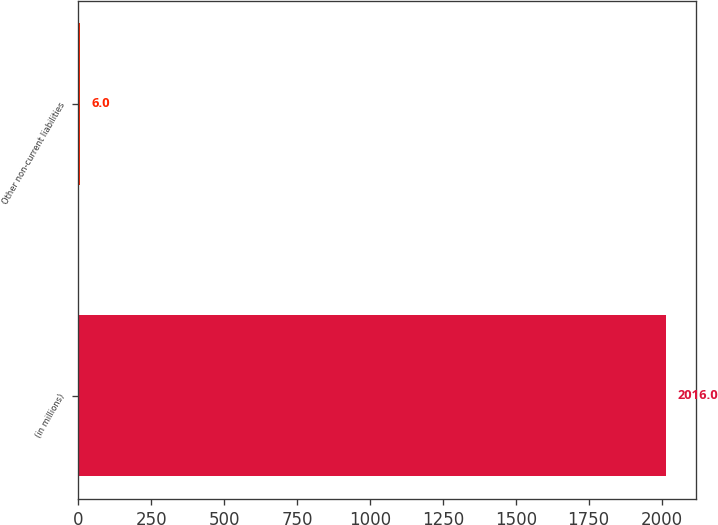Convert chart. <chart><loc_0><loc_0><loc_500><loc_500><bar_chart><fcel>(in millions)<fcel>Other non-current liabilities<nl><fcel>2016<fcel>6<nl></chart> 